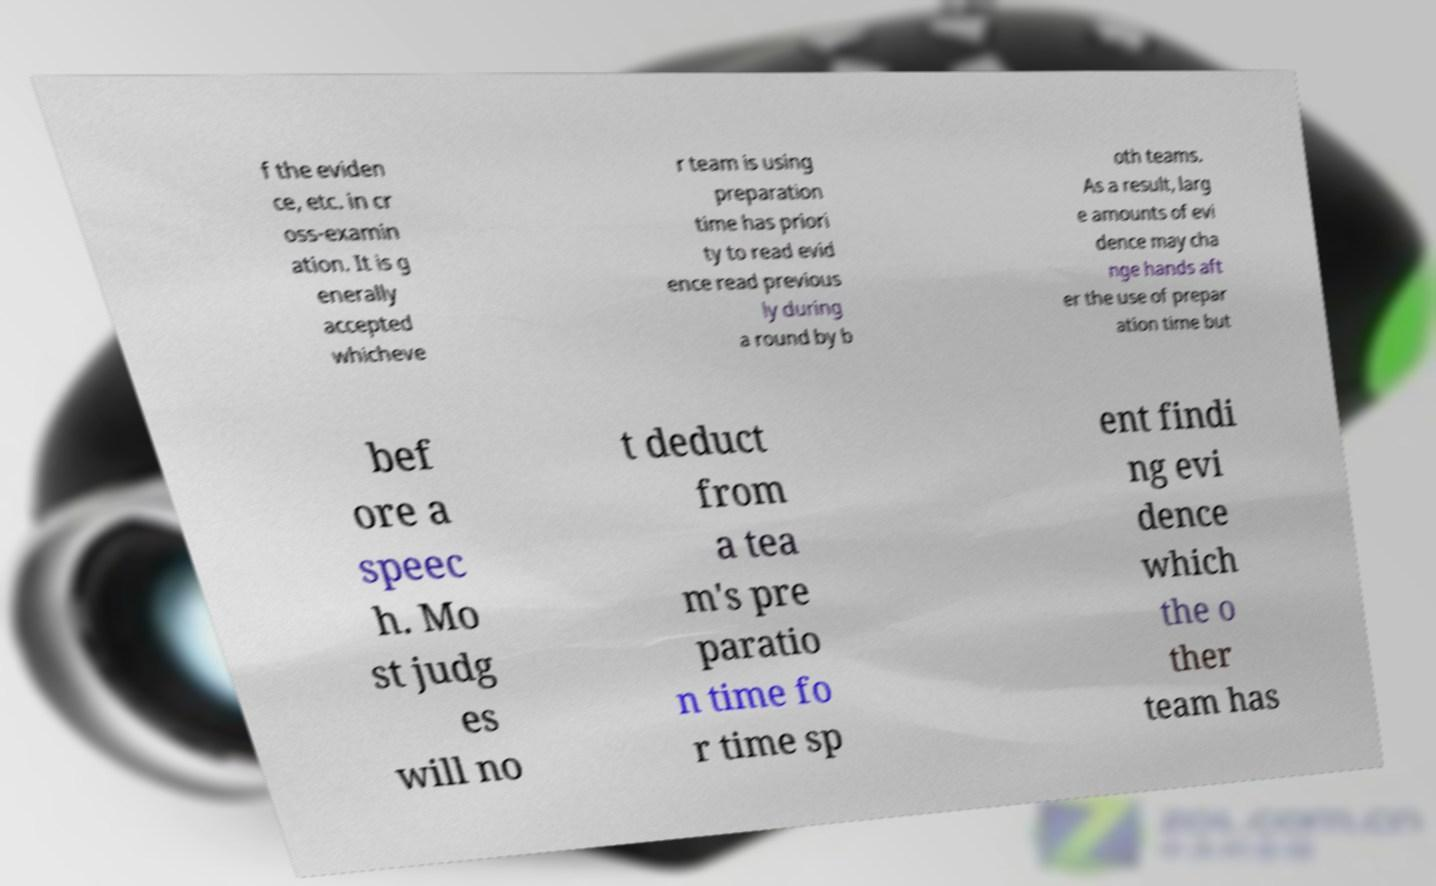Can you read and provide the text displayed in the image?This photo seems to have some interesting text. Can you extract and type it out for me? f the eviden ce, etc. in cr oss-examin ation. It is g enerally accepted whicheve r team is using preparation time has priori ty to read evid ence read previous ly during a round by b oth teams. As a result, larg e amounts of evi dence may cha nge hands aft er the use of prepar ation time but bef ore a speec h. Mo st judg es will no t deduct from a tea m's pre paratio n time fo r time sp ent findi ng evi dence which the o ther team has 